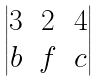<formula> <loc_0><loc_0><loc_500><loc_500>\begin{vmatrix} 3 & 2 & 4 \\ b & f & c \end{vmatrix}</formula> 